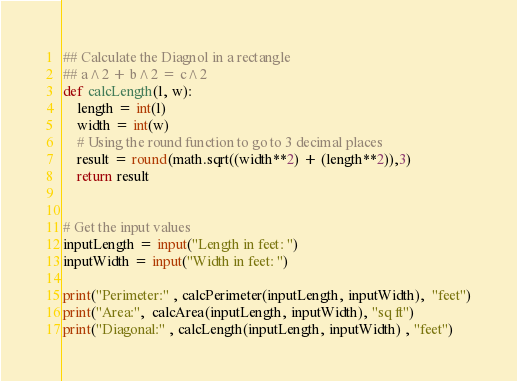Convert code to text. <code><loc_0><loc_0><loc_500><loc_500><_Python_>
## Calculate the Diagnol in a rectangle
## a^2 + b^2 = c^2
def calcLength(l, w):
    length = int(l)
    width = int(w)
    # Using the round function to go to 3 decimal places
    result = round(math.sqrt((width**2) + (length**2)),3)
    return result


# Get the input values
inputLength = input("Length in feet: ")
inputWidth = input("Width in feet: ")

print("Perimeter:" , calcPerimeter(inputLength, inputWidth),  "feet")
print("Area:",  calcArea(inputLength, inputWidth), "sq ft")
print("Diagonal:" , calcLength(inputLength, inputWidth) , "feet")</code> 